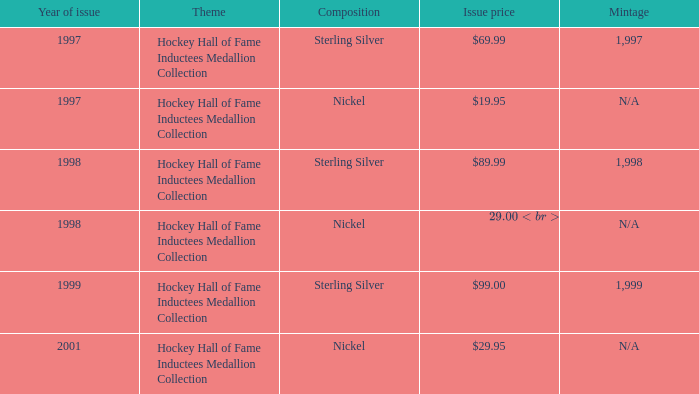00? Sterling Silver. 